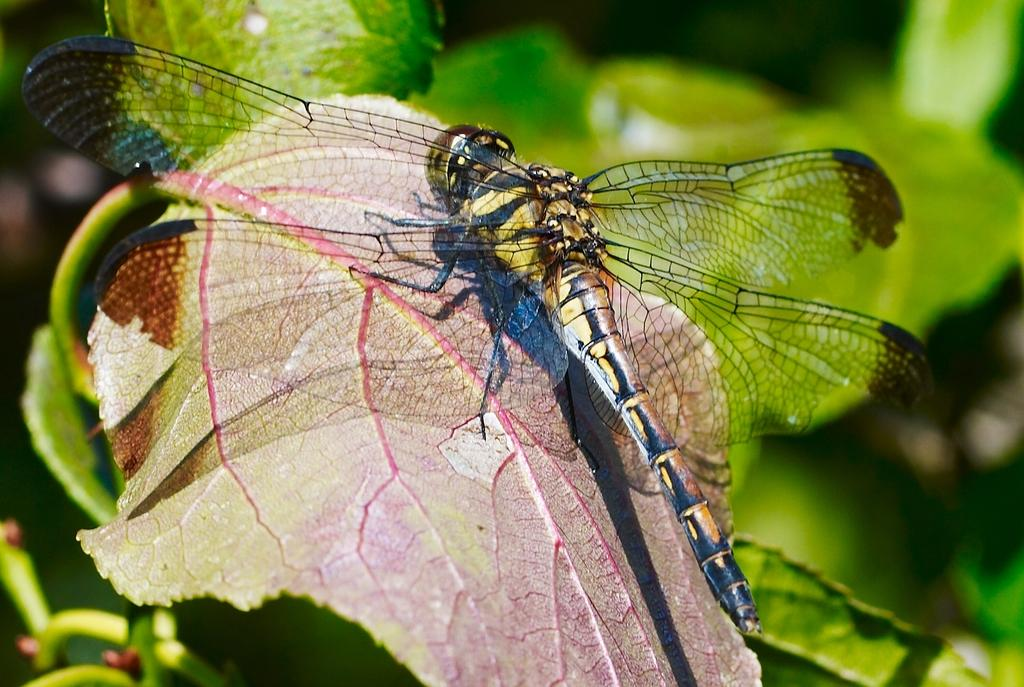What type of creature can be seen in the image? There is an insect in the image. Where is the insect located? The insect is on a leaf. Can you describe the background of the image? The background of the image is blurred. What type of sock is the insect wearing in the image? There is no sock present in the image, as insects do not wear clothing. Can you tell me how many calculators are visible in the image? There are no calculators present in the image. 